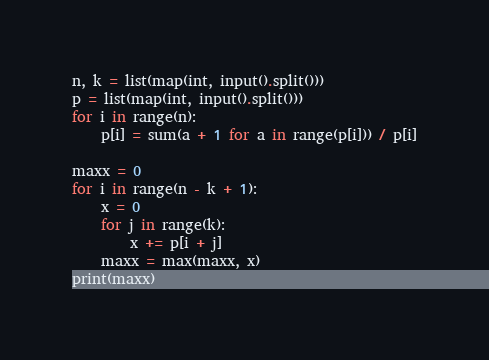<code> <loc_0><loc_0><loc_500><loc_500><_Python_>n, k = list(map(int, input().split()))
p = list(map(int, input().split()))
for i in range(n):
    p[i] = sum(a + 1 for a in range(p[i])) / p[i]

maxx = 0
for i in range(n - k + 1):
    x = 0
    for j in range(k):
        x += p[i + j]
    maxx = max(maxx, x)
print(maxx)
</code> 